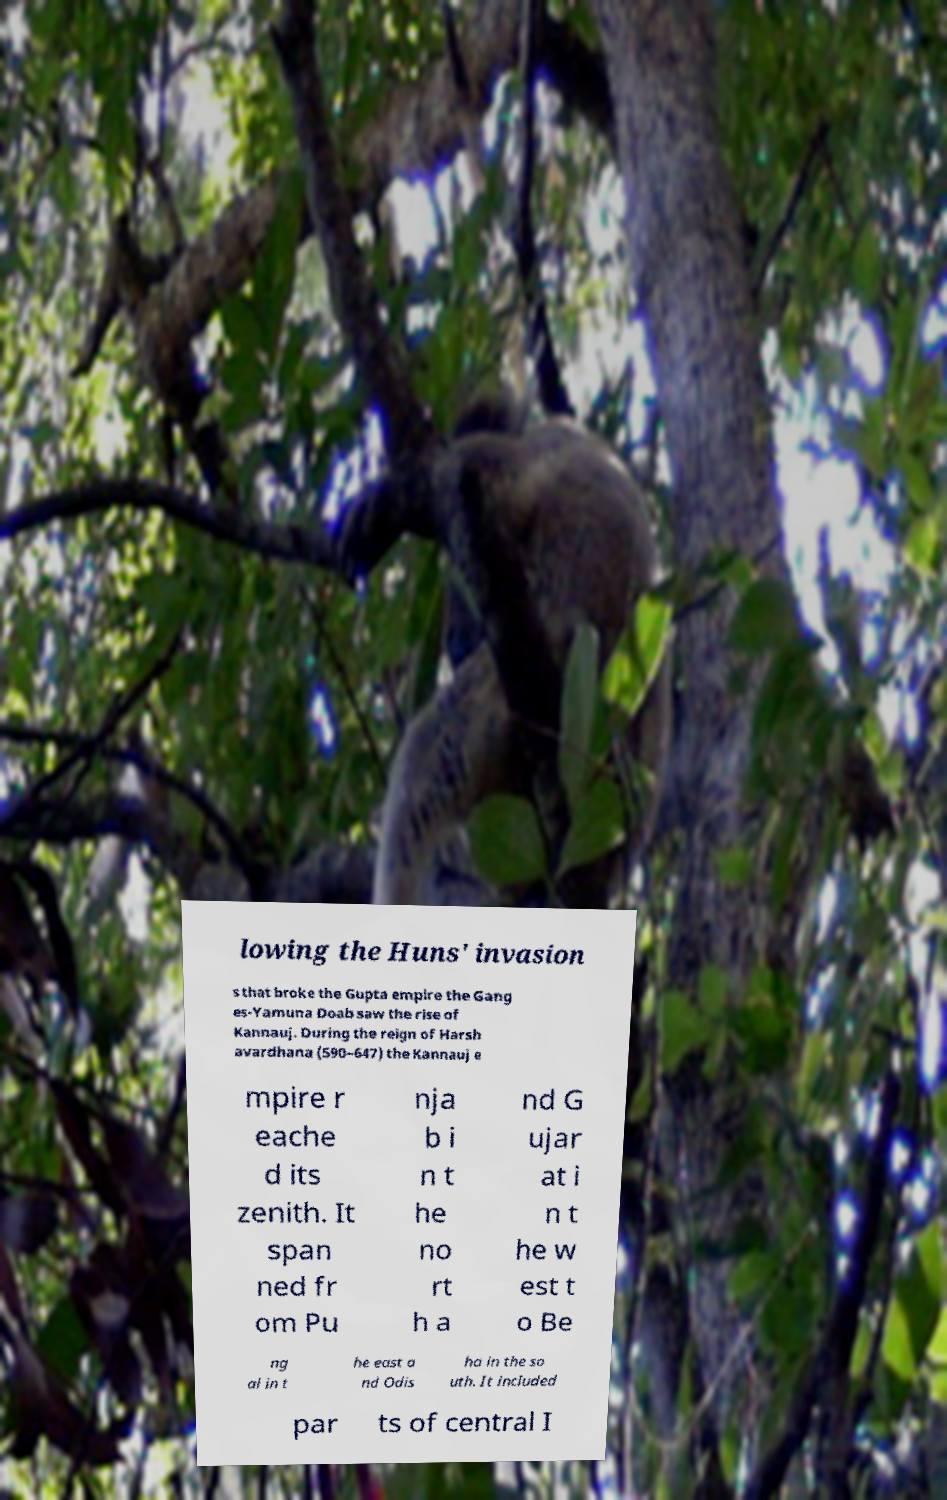Please read and relay the text visible in this image. What does it say? lowing the Huns' invasion s that broke the Gupta empire the Gang es-Yamuna Doab saw the rise of Kannauj. During the reign of Harsh avardhana (590–647) the Kannauj e mpire r eache d its zenith. It span ned fr om Pu nja b i n t he no rt h a nd G ujar at i n t he w est t o Be ng al in t he east a nd Odis ha in the so uth. It included par ts of central I 